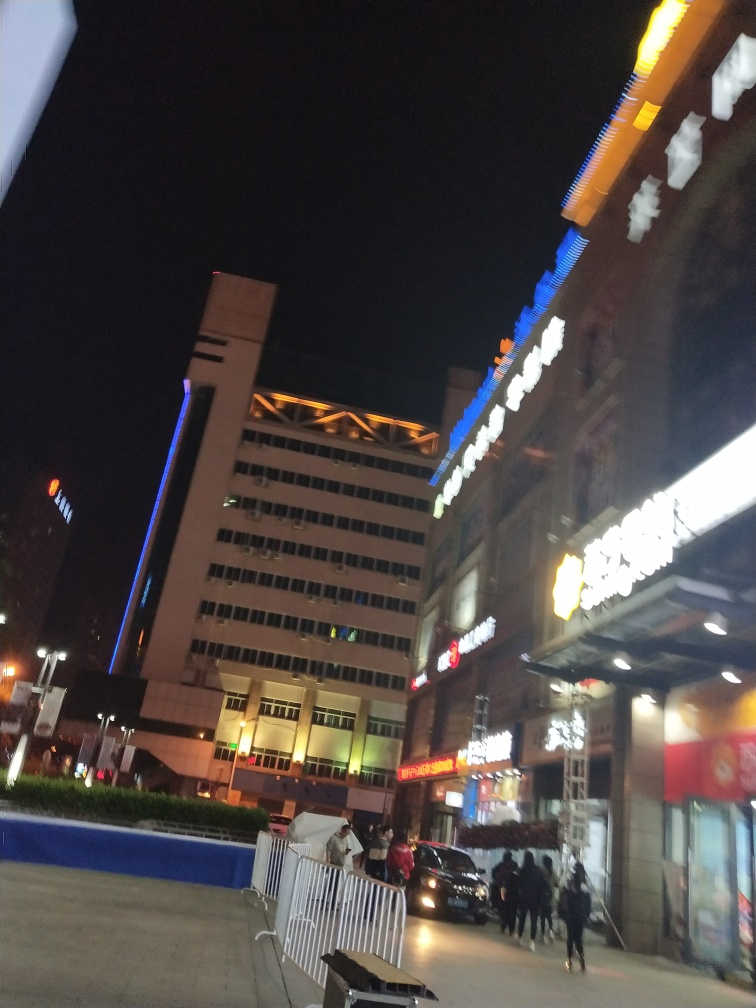How is the composition of the picture? The composition of the picture appears slightly imbalanced due to its angle and framing. It features an urban night scene with illuminated signage that draws the viewer's eye. However, the tilt of the camera results in a skewed perspective of the architecture, which can be seen as a creative choice or a flaw, depending on the photographer's intent. There is a dynamic sense of life with people moving and vehicles in mid-traffic, suggesting the liveliness of the area. 